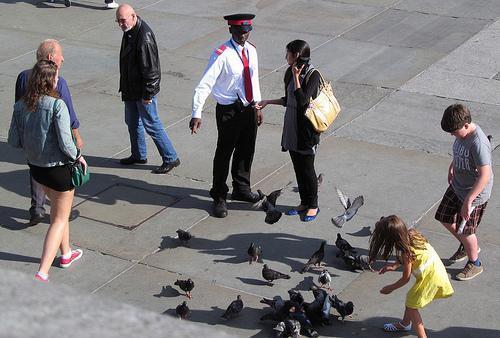How many people are pictured?
Give a very brief answer. 7. How many children are there?
Give a very brief answer. 2. 